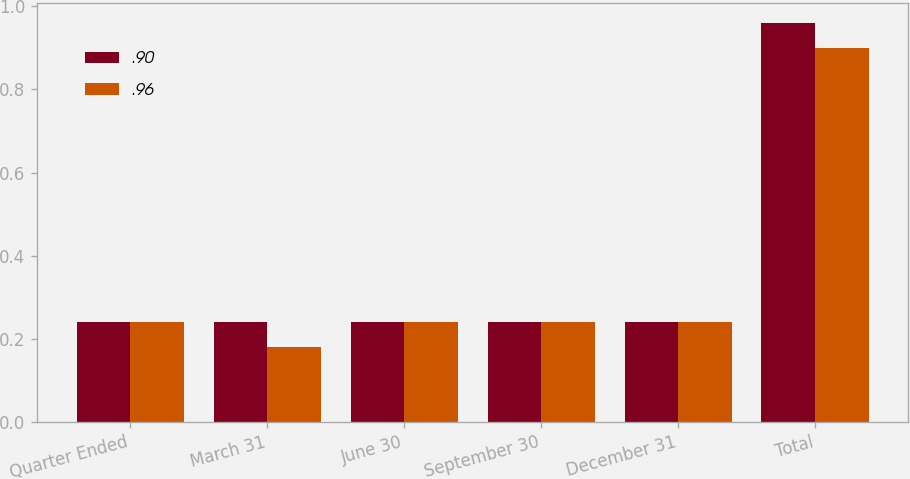Convert chart to OTSL. <chart><loc_0><loc_0><loc_500><loc_500><stacked_bar_chart><ecel><fcel>Quarter Ended<fcel>March 31<fcel>June 30<fcel>September 30<fcel>December 31<fcel>Total<nl><fcel>0.9<fcel>0.24<fcel>0.24<fcel>0.24<fcel>0.24<fcel>0.24<fcel>0.96<nl><fcel>0.96<fcel>0.24<fcel>0.18<fcel>0.24<fcel>0.24<fcel>0.24<fcel>0.9<nl></chart> 